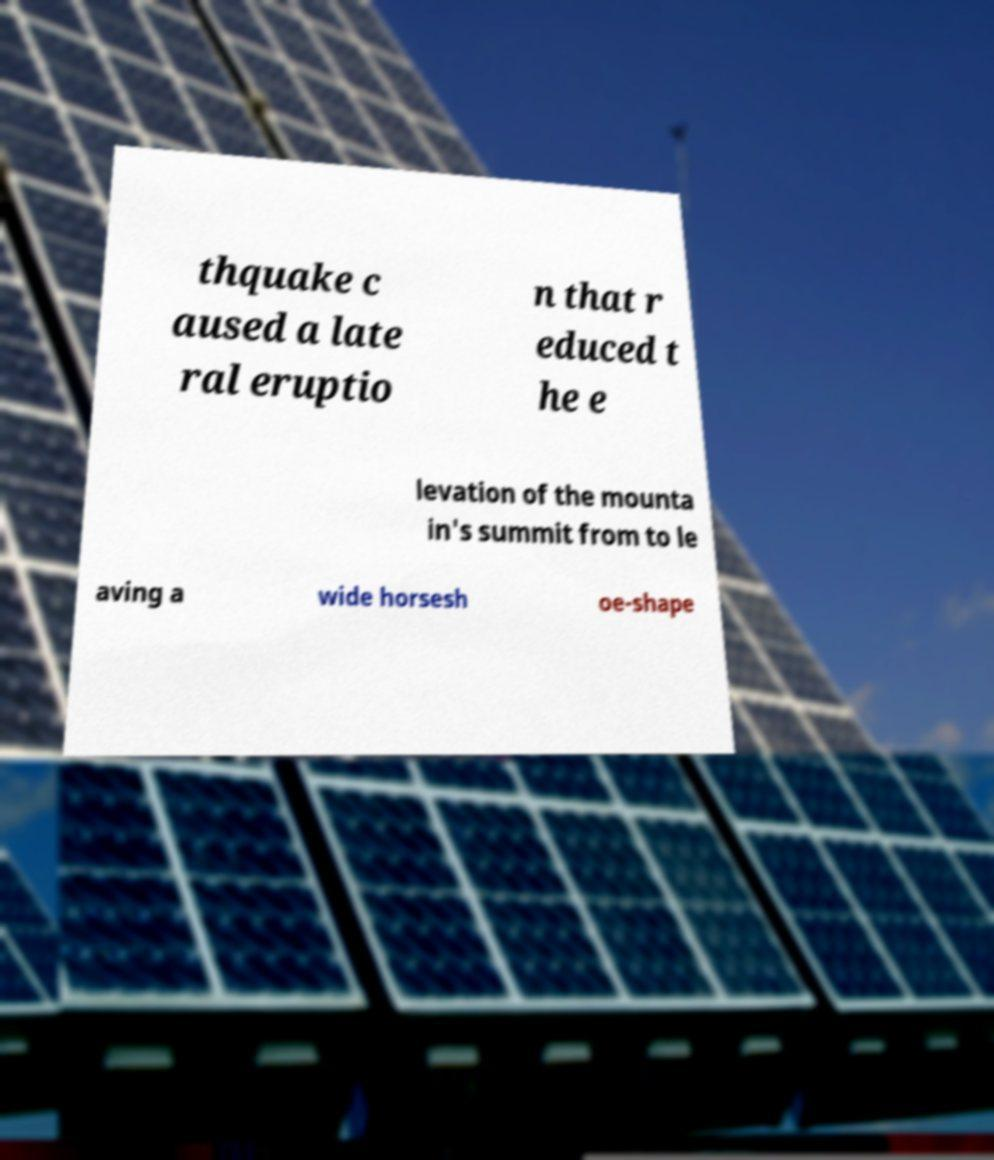I need the written content from this picture converted into text. Can you do that? thquake c aused a late ral eruptio n that r educed t he e levation of the mounta in's summit from to le aving a wide horsesh oe-shape 